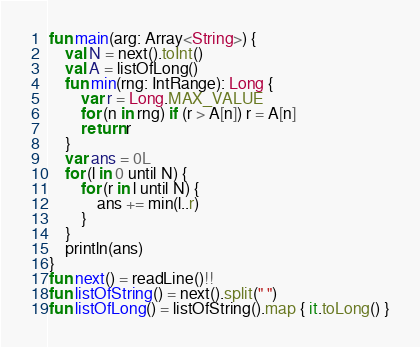Convert code to text. <code><loc_0><loc_0><loc_500><loc_500><_Kotlin_>fun main(arg: Array<String>) {
    val N = next().toInt()
    val A = listOfLong()
    fun min(rng: IntRange): Long {
		var r = Long.MAX_VALUE
    	for (n in rng) if (r > A[n]) r = A[n]
		return r
	}
    var ans = 0L
    for (l in 0 until N) {
        for (r in l until N) {
            ans += min(l..r)
        }
	}
    println(ans)
}
fun next() = readLine()!!
fun listOfString() = next().split(" ")
fun listOfLong() = listOfString().map { it.toLong() }
</code> 